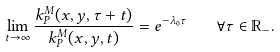<formula> <loc_0><loc_0><loc_500><loc_500>\lim _ { t \to \infty } \frac { k _ { P } ^ { M } ( x , y , \tau + t ) } { k _ { P } ^ { M } ( x , y , t ) } = e ^ { - \lambda _ { 0 } \tau } \quad \forall \tau \in \mathbb { R } _ { - } .</formula> 